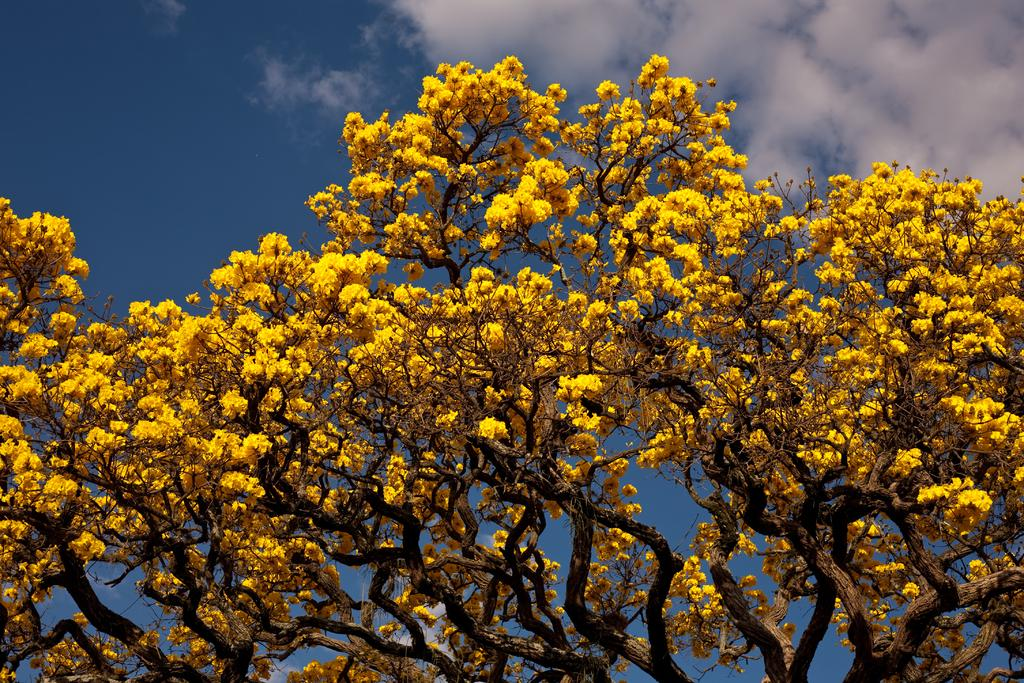What type of trees are present in the image? There are trees with yellow flowers in the image. What can be seen in the sky in the background of the image? There are clouds in the sky in the background of the image. How many seats are available in the middle of the image? There are no seats present in the image; it features trees with yellow flowers and clouds in the sky. 